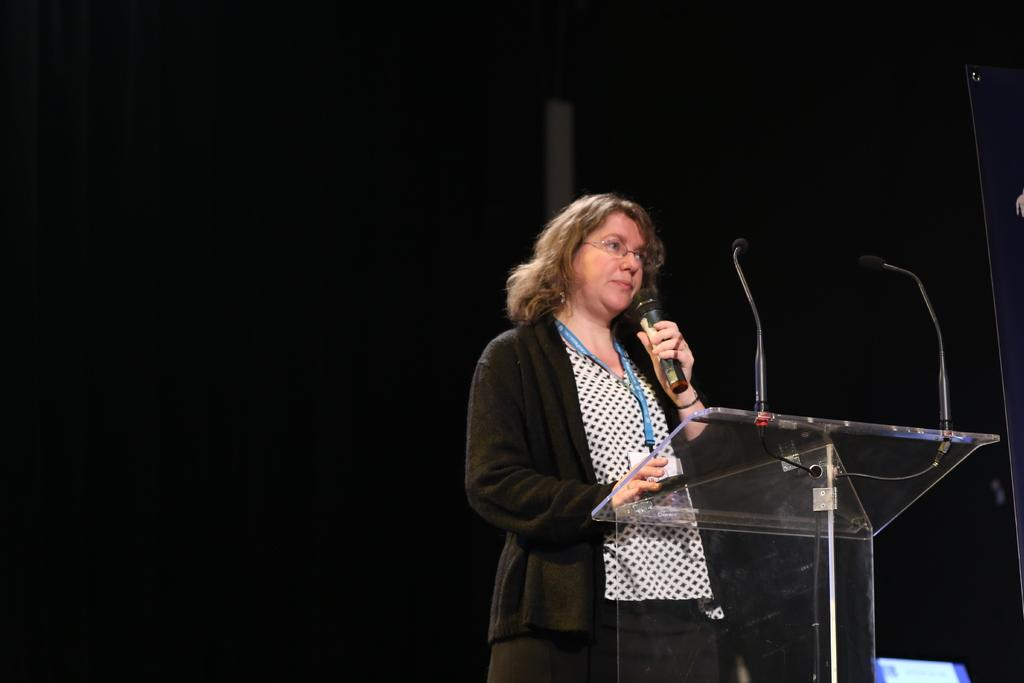Who is the main subject in the image? There is a woman in the image. What is the woman wearing? The woman is wearing a black jacket. What is the woman holding in the image? The woman is holding a mic. Can you describe the lighting in the image? The image is dark. What type of payment is being exchanged in the image? There is no payment being exchanged in the image; it features a woman holding a mic. Can you see the ocean in the background of the image? There is no ocean visible in the image; it is focused on the woman holding a mic. 